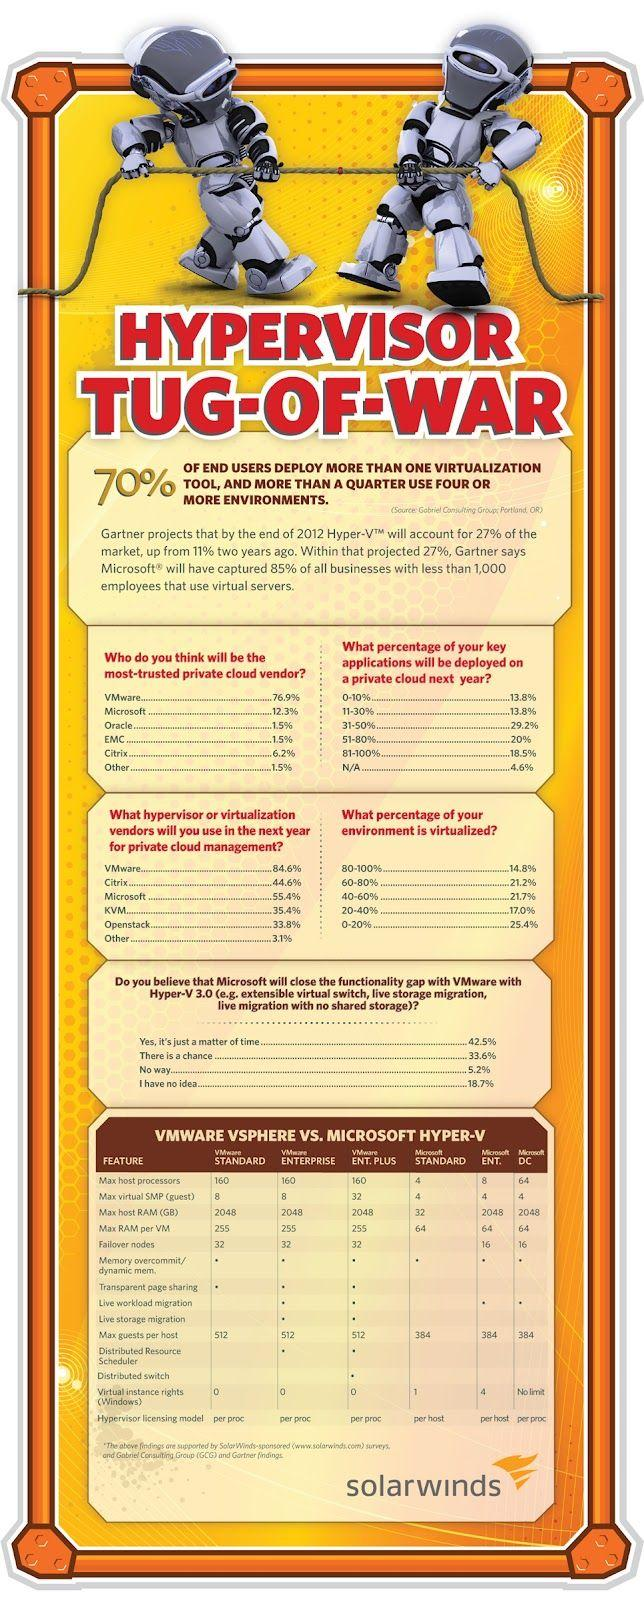List a handful of essential elements in this visual. How many Microsoft Hyper-Vs have Failover nodes equal to 16? The answer ranges from 2 to... There are three different types of Microsoft Hyper-V listed in the infographic. OpenStack is the virtual machine monitor that is expected to have the fifth rank in future private cloud management. VMware ESXi, a hypervisor, is capable of supporting a large number of virtual machines (guest machines) on a single physical server. However, the exact maximum number of guest machines that can be connected to VMware ESXi is dependent on several factors, including the resources available on the physical server (e.g., CPU, memory, storage), the workload of the virtual machines, and the specific version of VMware ESXi being used. As of VMware ESXi 6.5 Update 2, the maximum number of virtual machines that can be connected to a single ESXi host is 65535. For how many VMware virtual machines can the maximum number of processors be set to 160? The answer is between 3 and 3. 